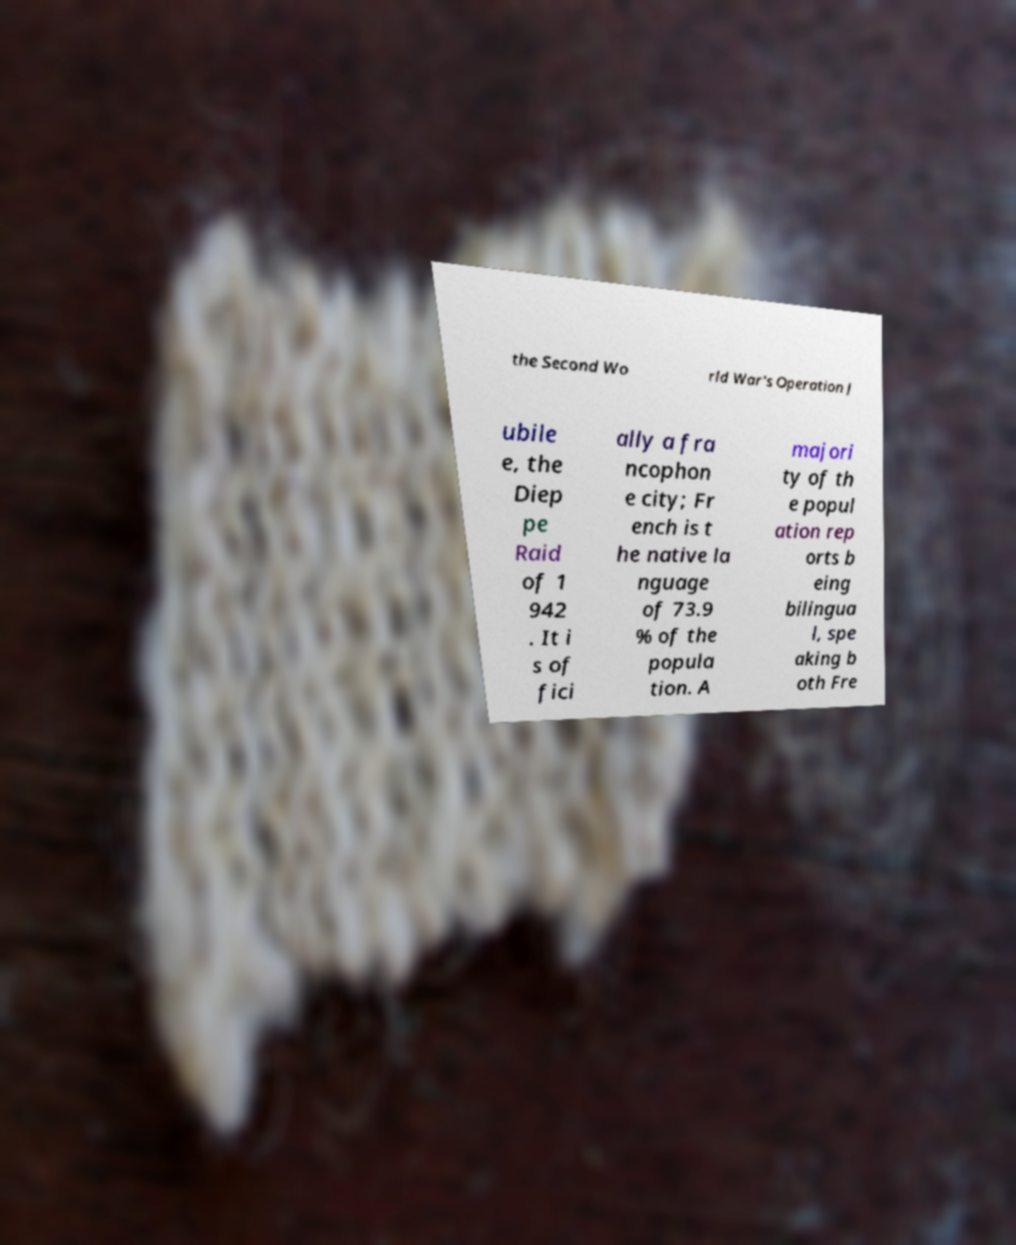There's text embedded in this image that I need extracted. Can you transcribe it verbatim? the Second Wo rld War's Operation J ubile e, the Diep pe Raid of 1 942 . It i s of fici ally a fra ncophon e city; Fr ench is t he native la nguage of 73.9 % of the popula tion. A majori ty of th e popul ation rep orts b eing bilingua l, spe aking b oth Fre 